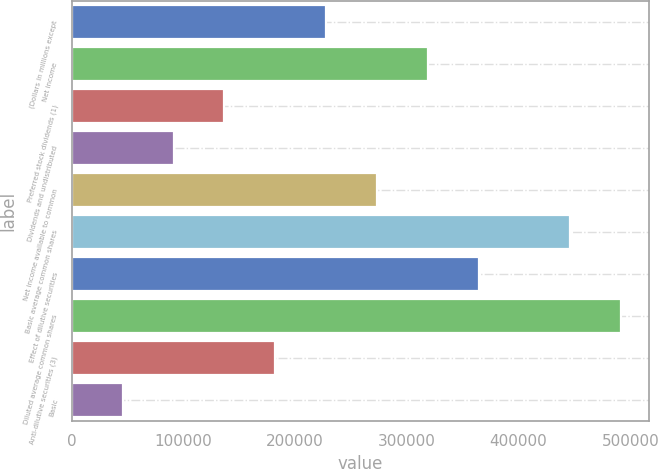Convert chart. <chart><loc_0><loc_0><loc_500><loc_500><bar_chart><fcel>(Dollars in millions except<fcel>Net income<fcel>Preferred stock dividends (1)<fcel>Dividends and undistributed<fcel>Net income available to common<fcel>Basic average common shares<fcel>Effect of dilutive securities<fcel>Diluted average common shares<fcel>Anti-dilutive securities (3)<fcel>Basic<nl><fcel>227580<fcel>318610<fcel>136550<fcel>91034.7<fcel>273095<fcel>446245<fcel>364125<fcel>491760<fcel>182065<fcel>45519.7<nl></chart> 